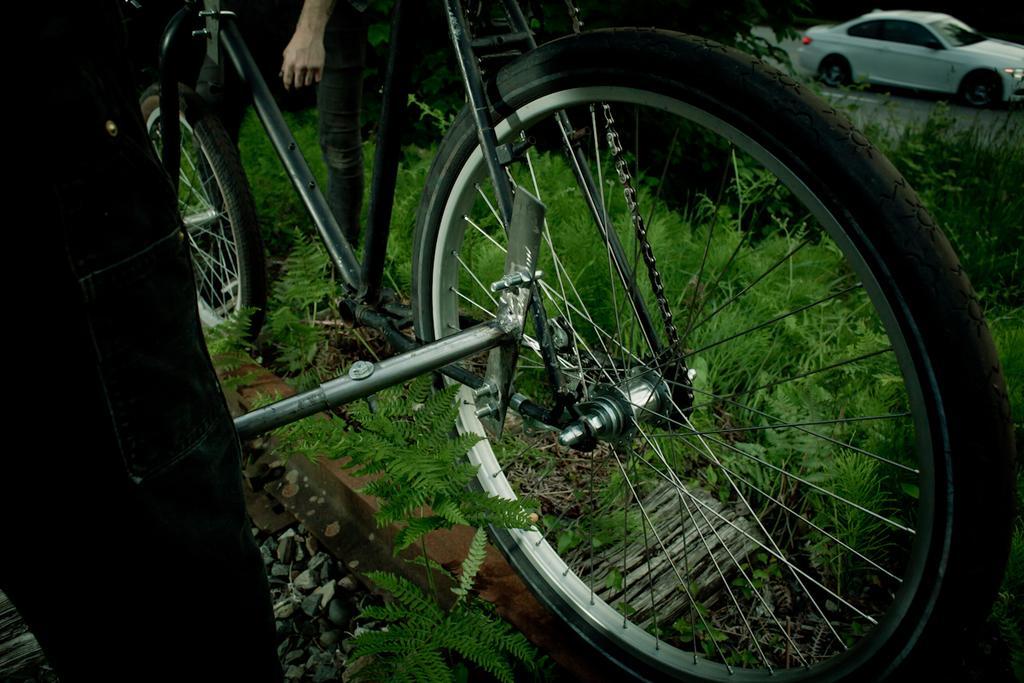Could you give a brief overview of what you see in this image? In this image I can see a bicycle and a person is standing on the grass ground. On the top right side of the image I can see a white colour car on the road. 